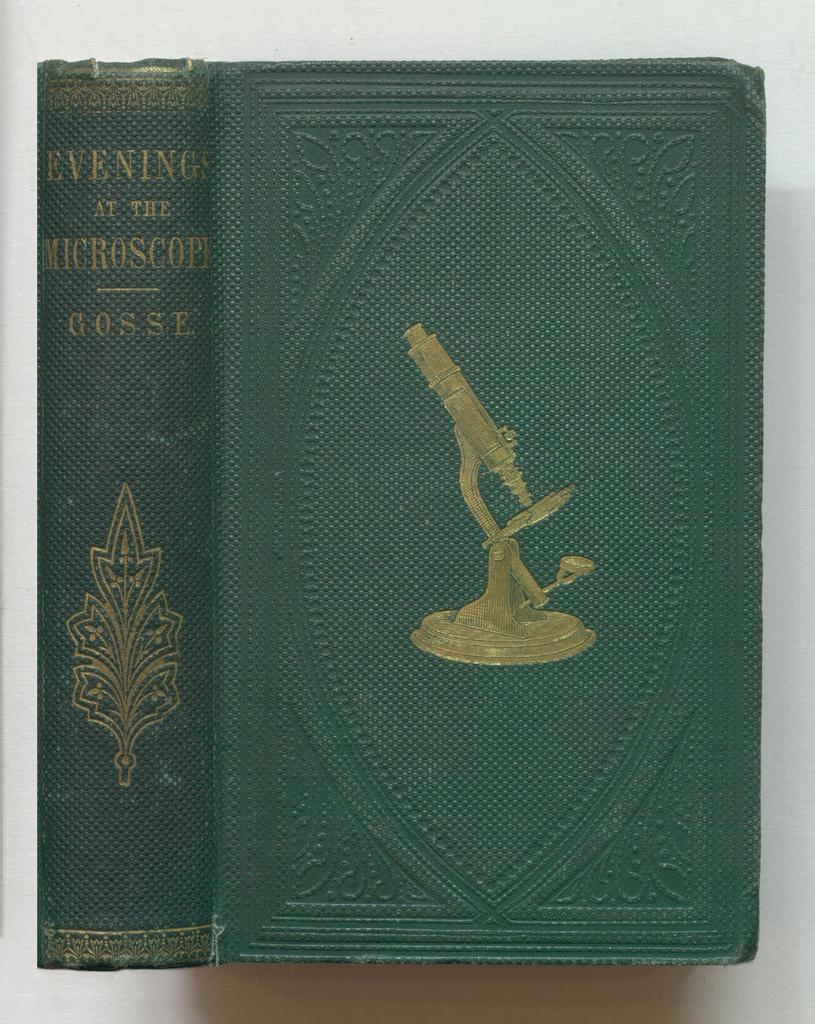Provide a one-sentence caption for the provided image. An antique book by Gosse is called Evenings at the Microscope. 